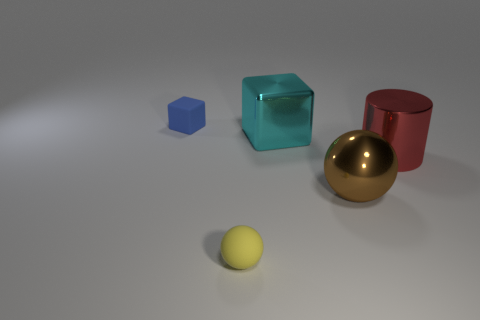Add 4 big gray cylinders. How many objects exist? 9 Subtract all cylinders. How many objects are left? 4 Subtract 0 gray spheres. How many objects are left? 5 Subtract all large shiny cubes. Subtract all cyan shiny things. How many objects are left? 3 Add 3 small yellow things. How many small yellow things are left? 4 Add 1 big red rubber things. How many big red rubber things exist? 1 